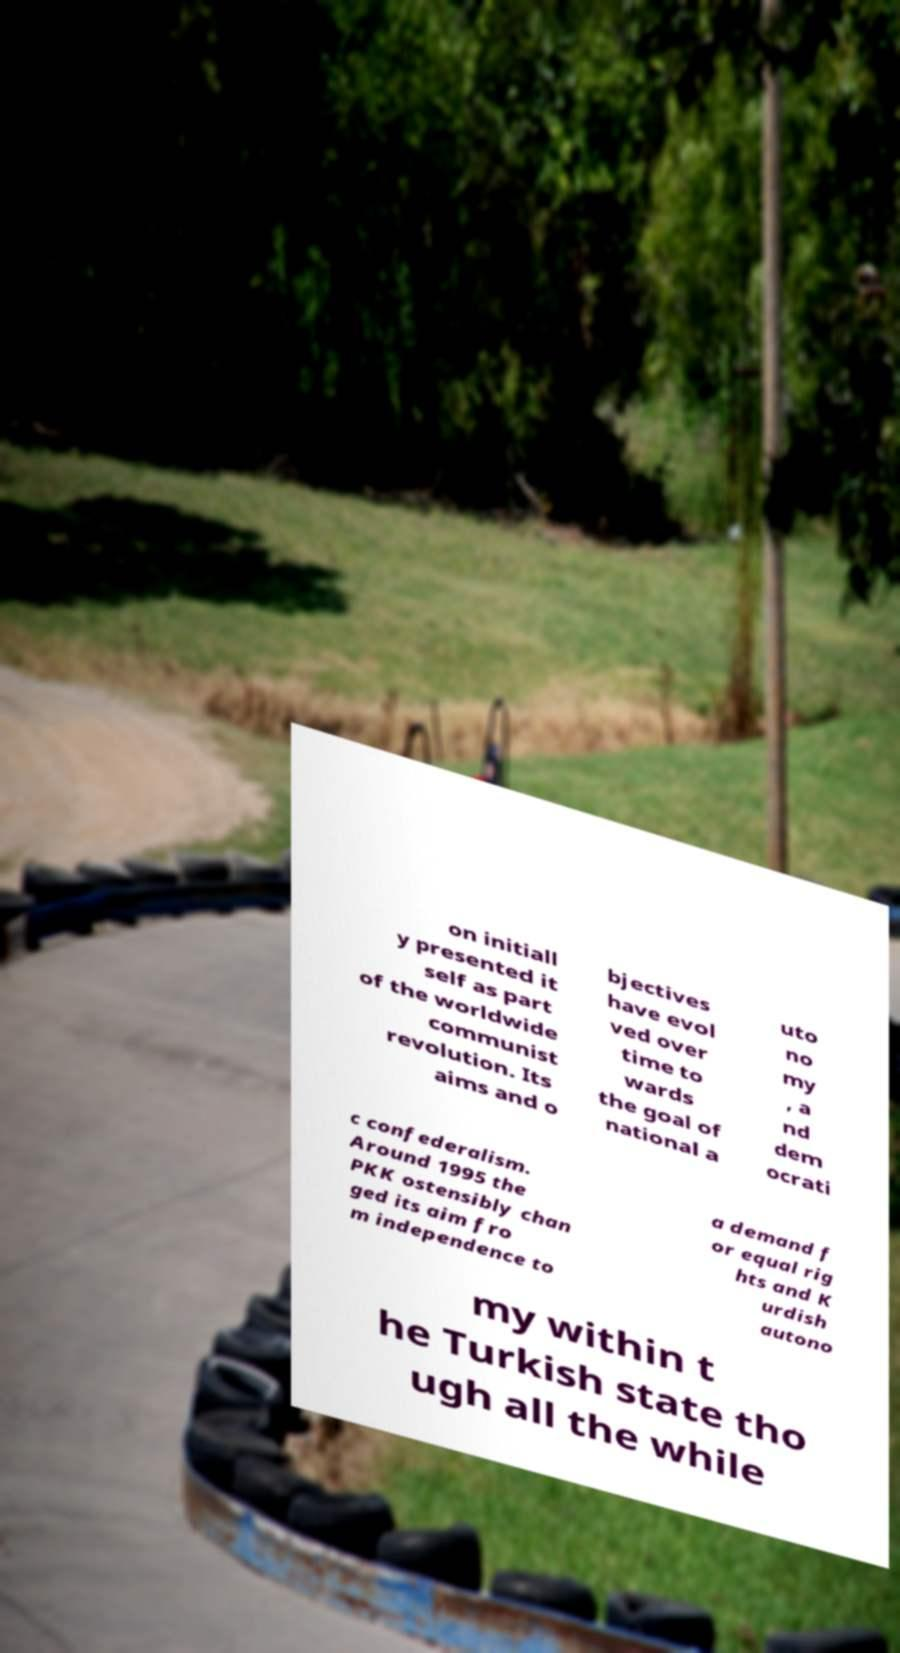Can you accurately transcribe the text from the provided image for me? on initiall y presented it self as part of the worldwide communist revolution. Its aims and o bjectives have evol ved over time to wards the goal of national a uto no my , a nd dem ocrati c confederalism. Around 1995 the PKK ostensibly chan ged its aim fro m independence to a demand f or equal rig hts and K urdish autono my within t he Turkish state tho ugh all the while 